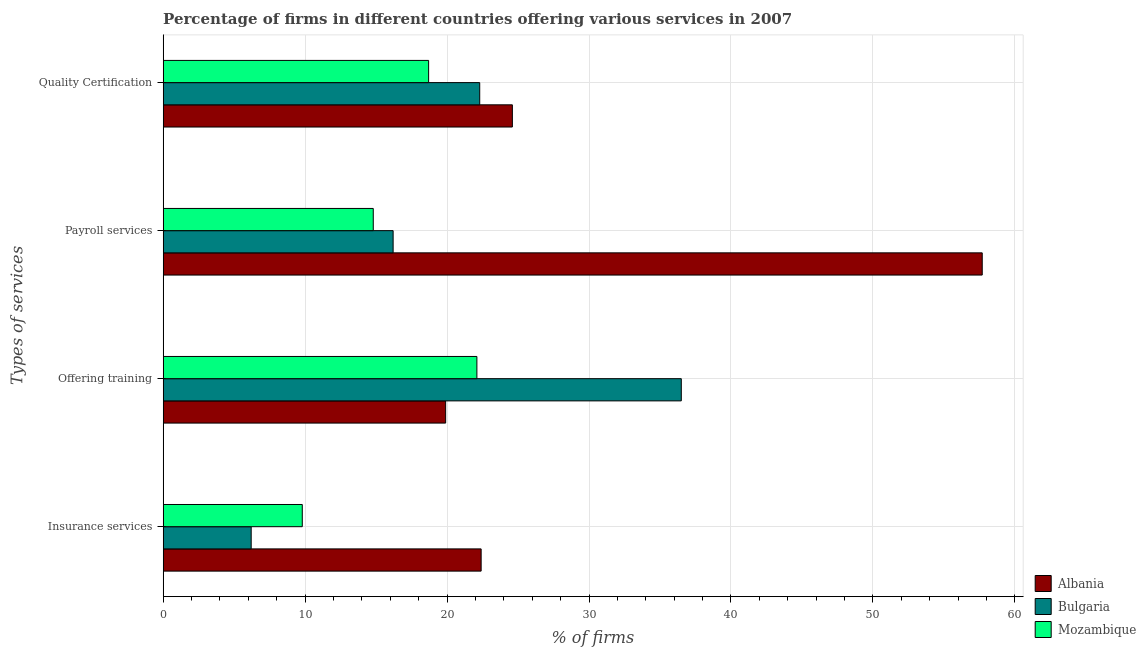How many groups of bars are there?
Ensure brevity in your answer.  4. Are the number of bars per tick equal to the number of legend labels?
Keep it short and to the point. Yes. Are the number of bars on each tick of the Y-axis equal?
Ensure brevity in your answer.  Yes. How many bars are there on the 1st tick from the top?
Ensure brevity in your answer.  3. How many bars are there on the 3rd tick from the bottom?
Your answer should be compact. 3. What is the label of the 2nd group of bars from the top?
Offer a terse response. Payroll services. Across all countries, what is the maximum percentage of firms offering insurance services?
Offer a terse response. 22.4. Across all countries, what is the minimum percentage of firms offering quality certification?
Keep it short and to the point. 18.7. In which country was the percentage of firms offering quality certification maximum?
Make the answer very short. Albania. In which country was the percentage of firms offering insurance services minimum?
Ensure brevity in your answer.  Bulgaria. What is the total percentage of firms offering training in the graph?
Give a very brief answer. 78.5. What is the difference between the percentage of firms offering payroll services in Albania and that in Bulgaria?
Make the answer very short. 41.5. What is the difference between the percentage of firms offering quality certification in Bulgaria and the percentage of firms offering training in Albania?
Provide a succinct answer. 2.4. What is the average percentage of firms offering insurance services per country?
Your answer should be compact. 12.8. In how many countries, is the percentage of firms offering insurance services greater than 38 %?
Ensure brevity in your answer.  0. What is the ratio of the percentage of firms offering quality certification in Albania to that in Mozambique?
Your answer should be compact. 1.32. Is the percentage of firms offering payroll services in Bulgaria less than that in Albania?
Your response must be concise. Yes. What is the difference between the highest and the second highest percentage of firms offering training?
Ensure brevity in your answer.  14.4. Is it the case that in every country, the sum of the percentage of firms offering payroll services and percentage of firms offering insurance services is greater than the sum of percentage of firms offering training and percentage of firms offering quality certification?
Your answer should be compact. No. What does the 2nd bar from the top in Insurance services represents?
Give a very brief answer. Bulgaria. How many countries are there in the graph?
Provide a succinct answer. 3. Are the values on the major ticks of X-axis written in scientific E-notation?
Provide a succinct answer. No. Does the graph contain any zero values?
Offer a terse response. No. Does the graph contain grids?
Your response must be concise. Yes. Where does the legend appear in the graph?
Keep it short and to the point. Bottom right. What is the title of the graph?
Make the answer very short. Percentage of firms in different countries offering various services in 2007. What is the label or title of the X-axis?
Provide a succinct answer. % of firms. What is the label or title of the Y-axis?
Ensure brevity in your answer.  Types of services. What is the % of firms of Albania in Insurance services?
Offer a terse response. 22.4. What is the % of firms in Bulgaria in Insurance services?
Give a very brief answer. 6.2. What is the % of firms in Mozambique in Insurance services?
Your answer should be very brief. 9.8. What is the % of firms in Albania in Offering training?
Provide a short and direct response. 19.9. What is the % of firms of Bulgaria in Offering training?
Your answer should be very brief. 36.5. What is the % of firms of Mozambique in Offering training?
Offer a terse response. 22.1. What is the % of firms of Albania in Payroll services?
Provide a short and direct response. 57.7. What is the % of firms in Albania in Quality Certification?
Provide a succinct answer. 24.6. What is the % of firms in Bulgaria in Quality Certification?
Your answer should be very brief. 22.3. What is the % of firms of Mozambique in Quality Certification?
Give a very brief answer. 18.7. Across all Types of services, what is the maximum % of firms in Albania?
Your response must be concise. 57.7. Across all Types of services, what is the maximum % of firms in Bulgaria?
Offer a very short reply. 36.5. Across all Types of services, what is the maximum % of firms in Mozambique?
Keep it short and to the point. 22.1. Across all Types of services, what is the minimum % of firms of Bulgaria?
Ensure brevity in your answer.  6.2. What is the total % of firms of Albania in the graph?
Offer a terse response. 124.6. What is the total % of firms in Bulgaria in the graph?
Give a very brief answer. 81.2. What is the total % of firms in Mozambique in the graph?
Ensure brevity in your answer.  65.4. What is the difference between the % of firms in Bulgaria in Insurance services and that in Offering training?
Provide a short and direct response. -30.3. What is the difference between the % of firms in Mozambique in Insurance services and that in Offering training?
Keep it short and to the point. -12.3. What is the difference between the % of firms in Albania in Insurance services and that in Payroll services?
Give a very brief answer. -35.3. What is the difference between the % of firms of Bulgaria in Insurance services and that in Payroll services?
Your answer should be very brief. -10. What is the difference between the % of firms of Albania in Insurance services and that in Quality Certification?
Ensure brevity in your answer.  -2.2. What is the difference between the % of firms of Bulgaria in Insurance services and that in Quality Certification?
Make the answer very short. -16.1. What is the difference between the % of firms in Mozambique in Insurance services and that in Quality Certification?
Keep it short and to the point. -8.9. What is the difference between the % of firms in Albania in Offering training and that in Payroll services?
Provide a succinct answer. -37.8. What is the difference between the % of firms in Bulgaria in Offering training and that in Payroll services?
Your answer should be very brief. 20.3. What is the difference between the % of firms in Mozambique in Offering training and that in Payroll services?
Your answer should be very brief. 7.3. What is the difference between the % of firms of Albania in Offering training and that in Quality Certification?
Provide a succinct answer. -4.7. What is the difference between the % of firms of Bulgaria in Offering training and that in Quality Certification?
Offer a terse response. 14.2. What is the difference between the % of firms of Mozambique in Offering training and that in Quality Certification?
Ensure brevity in your answer.  3.4. What is the difference between the % of firms of Albania in Payroll services and that in Quality Certification?
Offer a very short reply. 33.1. What is the difference between the % of firms of Albania in Insurance services and the % of firms of Bulgaria in Offering training?
Give a very brief answer. -14.1. What is the difference between the % of firms of Bulgaria in Insurance services and the % of firms of Mozambique in Offering training?
Provide a short and direct response. -15.9. What is the difference between the % of firms in Albania in Insurance services and the % of firms in Mozambique in Payroll services?
Provide a short and direct response. 7.6. What is the difference between the % of firms in Bulgaria in Insurance services and the % of firms in Mozambique in Payroll services?
Ensure brevity in your answer.  -8.6. What is the difference between the % of firms of Albania in Insurance services and the % of firms of Bulgaria in Quality Certification?
Your answer should be very brief. 0.1. What is the difference between the % of firms in Albania in Insurance services and the % of firms in Mozambique in Quality Certification?
Your answer should be very brief. 3.7. What is the difference between the % of firms of Albania in Offering training and the % of firms of Bulgaria in Payroll services?
Offer a very short reply. 3.7. What is the difference between the % of firms in Albania in Offering training and the % of firms in Mozambique in Payroll services?
Offer a terse response. 5.1. What is the difference between the % of firms of Bulgaria in Offering training and the % of firms of Mozambique in Payroll services?
Give a very brief answer. 21.7. What is the difference between the % of firms in Albania in Offering training and the % of firms in Mozambique in Quality Certification?
Offer a terse response. 1.2. What is the difference between the % of firms of Albania in Payroll services and the % of firms of Bulgaria in Quality Certification?
Provide a short and direct response. 35.4. What is the average % of firms of Albania per Types of services?
Provide a succinct answer. 31.15. What is the average % of firms in Bulgaria per Types of services?
Your answer should be compact. 20.3. What is the average % of firms in Mozambique per Types of services?
Keep it short and to the point. 16.35. What is the difference between the % of firms in Albania and % of firms in Mozambique in Insurance services?
Ensure brevity in your answer.  12.6. What is the difference between the % of firms of Albania and % of firms of Bulgaria in Offering training?
Provide a succinct answer. -16.6. What is the difference between the % of firms in Albania and % of firms in Mozambique in Offering training?
Your response must be concise. -2.2. What is the difference between the % of firms of Albania and % of firms of Bulgaria in Payroll services?
Provide a short and direct response. 41.5. What is the difference between the % of firms of Albania and % of firms of Mozambique in Payroll services?
Keep it short and to the point. 42.9. What is the difference between the % of firms of Albania and % of firms of Bulgaria in Quality Certification?
Your answer should be compact. 2.3. What is the difference between the % of firms in Albania and % of firms in Mozambique in Quality Certification?
Your answer should be very brief. 5.9. What is the difference between the % of firms in Bulgaria and % of firms in Mozambique in Quality Certification?
Your answer should be compact. 3.6. What is the ratio of the % of firms of Albania in Insurance services to that in Offering training?
Ensure brevity in your answer.  1.13. What is the ratio of the % of firms of Bulgaria in Insurance services to that in Offering training?
Offer a terse response. 0.17. What is the ratio of the % of firms of Mozambique in Insurance services to that in Offering training?
Your response must be concise. 0.44. What is the ratio of the % of firms of Albania in Insurance services to that in Payroll services?
Give a very brief answer. 0.39. What is the ratio of the % of firms in Bulgaria in Insurance services to that in Payroll services?
Your answer should be compact. 0.38. What is the ratio of the % of firms in Mozambique in Insurance services to that in Payroll services?
Make the answer very short. 0.66. What is the ratio of the % of firms of Albania in Insurance services to that in Quality Certification?
Ensure brevity in your answer.  0.91. What is the ratio of the % of firms in Bulgaria in Insurance services to that in Quality Certification?
Offer a terse response. 0.28. What is the ratio of the % of firms in Mozambique in Insurance services to that in Quality Certification?
Provide a short and direct response. 0.52. What is the ratio of the % of firms in Albania in Offering training to that in Payroll services?
Offer a terse response. 0.34. What is the ratio of the % of firms in Bulgaria in Offering training to that in Payroll services?
Your response must be concise. 2.25. What is the ratio of the % of firms of Mozambique in Offering training to that in Payroll services?
Your answer should be compact. 1.49. What is the ratio of the % of firms in Albania in Offering training to that in Quality Certification?
Ensure brevity in your answer.  0.81. What is the ratio of the % of firms in Bulgaria in Offering training to that in Quality Certification?
Make the answer very short. 1.64. What is the ratio of the % of firms in Mozambique in Offering training to that in Quality Certification?
Your response must be concise. 1.18. What is the ratio of the % of firms in Albania in Payroll services to that in Quality Certification?
Provide a short and direct response. 2.35. What is the ratio of the % of firms of Bulgaria in Payroll services to that in Quality Certification?
Keep it short and to the point. 0.73. What is the ratio of the % of firms of Mozambique in Payroll services to that in Quality Certification?
Your answer should be compact. 0.79. What is the difference between the highest and the second highest % of firms of Albania?
Provide a short and direct response. 33.1. What is the difference between the highest and the second highest % of firms of Mozambique?
Keep it short and to the point. 3.4. What is the difference between the highest and the lowest % of firms in Albania?
Your answer should be compact. 37.8. What is the difference between the highest and the lowest % of firms of Bulgaria?
Provide a succinct answer. 30.3. 